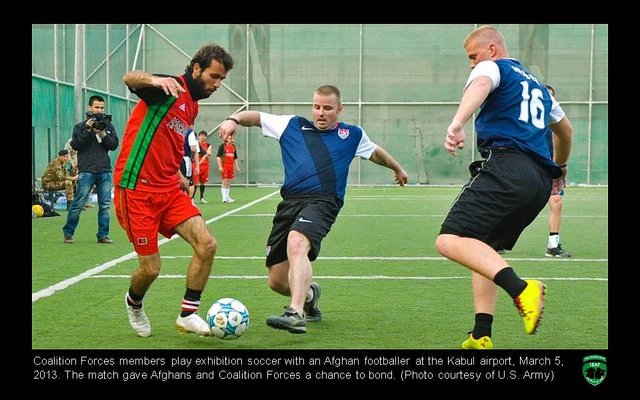Describe the objects in this image and their specific colors. I can see people in black, navy, white, and tan tones, people in black, red, brown, and olive tones, people in black, navy, and blue tones, people in black, teal, darkblue, and gray tones, and sports ball in black, ivory, darkgray, green, and lightblue tones in this image. 